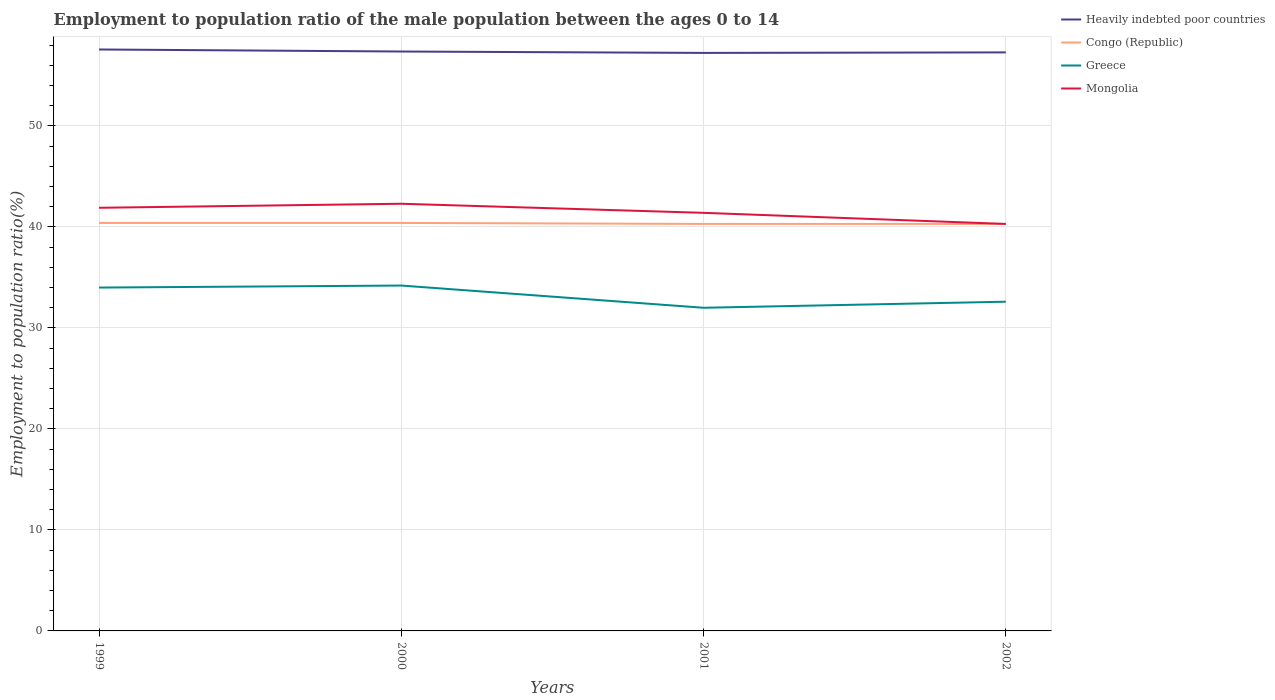Across all years, what is the maximum employment to population ratio in Mongolia?
Offer a very short reply. 40.3. In which year was the employment to population ratio in Mongolia maximum?
Offer a very short reply. 2002. What is the total employment to population ratio in Congo (Republic) in the graph?
Give a very brief answer. 0.1. What is the difference between the highest and the second highest employment to population ratio in Greece?
Provide a succinct answer. 2.2. How many lines are there?
Keep it short and to the point. 4. How many years are there in the graph?
Keep it short and to the point. 4. Are the values on the major ticks of Y-axis written in scientific E-notation?
Your answer should be compact. No. How many legend labels are there?
Provide a short and direct response. 4. How are the legend labels stacked?
Provide a short and direct response. Vertical. What is the title of the graph?
Provide a short and direct response. Employment to population ratio of the male population between the ages 0 to 14. What is the label or title of the X-axis?
Offer a very short reply. Years. What is the Employment to population ratio(%) in Heavily indebted poor countries in 1999?
Provide a succinct answer. 57.57. What is the Employment to population ratio(%) of Congo (Republic) in 1999?
Give a very brief answer. 40.4. What is the Employment to population ratio(%) in Greece in 1999?
Offer a terse response. 34. What is the Employment to population ratio(%) of Mongolia in 1999?
Make the answer very short. 41.9. What is the Employment to population ratio(%) of Heavily indebted poor countries in 2000?
Your answer should be compact. 57.37. What is the Employment to population ratio(%) of Congo (Republic) in 2000?
Provide a short and direct response. 40.4. What is the Employment to population ratio(%) in Greece in 2000?
Provide a short and direct response. 34.2. What is the Employment to population ratio(%) in Mongolia in 2000?
Provide a succinct answer. 42.3. What is the Employment to population ratio(%) of Heavily indebted poor countries in 2001?
Provide a short and direct response. 57.24. What is the Employment to population ratio(%) of Congo (Republic) in 2001?
Give a very brief answer. 40.3. What is the Employment to population ratio(%) in Greece in 2001?
Make the answer very short. 32. What is the Employment to population ratio(%) of Mongolia in 2001?
Offer a terse response. 41.4. What is the Employment to population ratio(%) of Heavily indebted poor countries in 2002?
Your response must be concise. 57.29. What is the Employment to population ratio(%) of Congo (Republic) in 2002?
Provide a short and direct response. 40.3. What is the Employment to population ratio(%) of Greece in 2002?
Your answer should be very brief. 32.6. What is the Employment to population ratio(%) in Mongolia in 2002?
Provide a succinct answer. 40.3. Across all years, what is the maximum Employment to population ratio(%) of Heavily indebted poor countries?
Your answer should be compact. 57.57. Across all years, what is the maximum Employment to population ratio(%) in Congo (Republic)?
Provide a succinct answer. 40.4. Across all years, what is the maximum Employment to population ratio(%) of Greece?
Offer a very short reply. 34.2. Across all years, what is the maximum Employment to population ratio(%) of Mongolia?
Make the answer very short. 42.3. Across all years, what is the minimum Employment to population ratio(%) in Heavily indebted poor countries?
Keep it short and to the point. 57.24. Across all years, what is the minimum Employment to population ratio(%) of Congo (Republic)?
Your response must be concise. 40.3. Across all years, what is the minimum Employment to population ratio(%) of Mongolia?
Keep it short and to the point. 40.3. What is the total Employment to population ratio(%) of Heavily indebted poor countries in the graph?
Give a very brief answer. 229.47. What is the total Employment to population ratio(%) of Congo (Republic) in the graph?
Offer a very short reply. 161.4. What is the total Employment to population ratio(%) of Greece in the graph?
Provide a succinct answer. 132.8. What is the total Employment to population ratio(%) of Mongolia in the graph?
Your response must be concise. 165.9. What is the difference between the Employment to population ratio(%) of Heavily indebted poor countries in 1999 and that in 2000?
Offer a terse response. 0.2. What is the difference between the Employment to population ratio(%) of Greece in 1999 and that in 2000?
Make the answer very short. -0.2. What is the difference between the Employment to population ratio(%) of Mongolia in 1999 and that in 2000?
Your answer should be very brief. -0.4. What is the difference between the Employment to population ratio(%) of Heavily indebted poor countries in 1999 and that in 2001?
Ensure brevity in your answer.  0.34. What is the difference between the Employment to population ratio(%) in Greece in 1999 and that in 2001?
Your answer should be very brief. 2. What is the difference between the Employment to population ratio(%) in Heavily indebted poor countries in 1999 and that in 2002?
Your answer should be very brief. 0.29. What is the difference between the Employment to population ratio(%) of Congo (Republic) in 1999 and that in 2002?
Provide a short and direct response. 0.1. What is the difference between the Employment to population ratio(%) of Heavily indebted poor countries in 2000 and that in 2001?
Provide a short and direct response. 0.14. What is the difference between the Employment to population ratio(%) of Greece in 2000 and that in 2001?
Offer a very short reply. 2.2. What is the difference between the Employment to population ratio(%) of Heavily indebted poor countries in 2000 and that in 2002?
Keep it short and to the point. 0.09. What is the difference between the Employment to population ratio(%) of Greece in 2000 and that in 2002?
Make the answer very short. 1.6. What is the difference between the Employment to population ratio(%) in Mongolia in 2000 and that in 2002?
Keep it short and to the point. 2. What is the difference between the Employment to population ratio(%) in Heavily indebted poor countries in 2001 and that in 2002?
Offer a very short reply. -0.05. What is the difference between the Employment to population ratio(%) in Congo (Republic) in 2001 and that in 2002?
Ensure brevity in your answer.  0. What is the difference between the Employment to population ratio(%) of Heavily indebted poor countries in 1999 and the Employment to population ratio(%) of Congo (Republic) in 2000?
Give a very brief answer. 17.17. What is the difference between the Employment to population ratio(%) in Heavily indebted poor countries in 1999 and the Employment to population ratio(%) in Greece in 2000?
Offer a very short reply. 23.37. What is the difference between the Employment to population ratio(%) of Heavily indebted poor countries in 1999 and the Employment to population ratio(%) of Mongolia in 2000?
Offer a very short reply. 15.27. What is the difference between the Employment to population ratio(%) of Congo (Republic) in 1999 and the Employment to population ratio(%) of Mongolia in 2000?
Offer a very short reply. -1.9. What is the difference between the Employment to population ratio(%) in Heavily indebted poor countries in 1999 and the Employment to population ratio(%) in Congo (Republic) in 2001?
Give a very brief answer. 17.27. What is the difference between the Employment to population ratio(%) in Heavily indebted poor countries in 1999 and the Employment to population ratio(%) in Greece in 2001?
Your answer should be compact. 25.57. What is the difference between the Employment to population ratio(%) of Heavily indebted poor countries in 1999 and the Employment to population ratio(%) of Mongolia in 2001?
Ensure brevity in your answer.  16.17. What is the difference between the Employment to population ratio(%) of Congo (Republic) in 1999 and the Employment to population ratio(%) of Greece in 2001?
Your answer should be very brief. 8.4. What is the difference between the Employment to population ratio(%) in Heavily indebted poor countries in 1999 and the Employment to population ratio(%) in Congo (Republic) in 2002?
Your answer should be compact. 17.27. What is the difference between the Employment to population ratio(%) in Heavily indebted poor countries in 1999 and the Employment to population ratio(%) in Greece in 2002?
Provide a short and direct response. 24.97. What is the difference between the Employment to population ratio(%) of Heavily indebted poor countries in 1999 and the Employment to population ratio(%) of Mongolia in 2002?
Make the answer very short. 17.27. What is the difference between the Employment to population ratio(%) in Congo (Republic) in 1999 and the Employment to population ratio(%) in Greece in 2002?
Provide a short and direct response. 7.8. What is the difference between the Employment to population ratio(%) in Congo (Republic) in 1999 and the Employment to population ratio(%) in Mongolia in 2002?
Your answer should be very brief. 0.1. What is the difference between the Employment to population ratio(%) of Greece in 1999 and the Employment to population ratio(%) of Mongolia in 2002?
Provide a succinct answer. -6.3. What is the difference between the Employment to population ratio(%) in Heavily indebted poor countries in 2000 and the Employment to population ratio(%) in Congo (Republic) in 2001?
Give a very brief answer. 17.07. What is the difference between the Employment to population ratio(%) in Heavily indebted poor countries in 2000 and the Employment to population ratio(%) in Greece in 2001?
Make the answer very short. 25.37. What is the difference between the Employment to population ratio(%) in Heavily indebted poor countries in 2000 and the Employment to population ratio(%) in Mongolia in 2001?
Your response must be concise. 15.97. What is the difference between the Employment to population ratio(%) in Greece in 2000 and the Employment to population ratio(%) in Mongolia in 2001?
Keep it short and to the point. -7.2. What is the difference between the Employment to population ratio(%) of Heavily indebted poor countries in 2000 and the Employment to population ratio(%) of Congo (Republic) in 2002?
Make the answer very short. 17.07. What is the difference between the Employment to population ratio(%) in Heavily indebted poor countries in 2000 and the Employment to population ratio(%) in Greece in 2002?
Keep it short and to the point. 24.77. What is the difference between the Employment to population ratio(%) of Heavily indebted poor countries in 2000 and the Employment to population ratio(%) of Mongolia in 2002?
Keep it short and to the point. 17.07. What is the difference between the Employment to population ratio(%) in Greece in 2000 and the Employment to population ratio(%) in Mongolia in 2002?
Offer a terse response. -6.1. What is the difference between the Employment to population ratio(%) in Heavily indebted poor countries in 2001 and the Employment to population ratio(%) in Congo (Republic) in 2002?
Ensure brevity in your answer.  16.94. What is the difference between the Employment to population ratio(%) in Heavily indebted poor countries in 2001 and the Employment to population ratio(%) in Greece in 2002?
Give a very brief answer. 24.64. What is the difference between the Employment to population ratio(%) in Heavily indebted poor countries in 2001 and the Employment to population ratio(%) in Mongolia in 2002?
Offer a terse response. 16.94. What is the difference between the Employment to population ratio(%) of Congo (Republic) in 2001 and the Employment to population ratio(%) of Greece in 2002?
Give a very brief answer. 7.7. What is the difference between the Employment to population ratio(%) of Congo (Republic) in 2001 and the Employment to population ratio(%) of Mongolia in 2002?
Provide a succinct answer. 0. What is the average Employment to population ratio(%) of Heavily indebted poor countries per year?
Provide a short and direct response. 57.37. What is the average Employment to population ratio(%) of Congo (Republic) per year?
Make the answer very short. 40.35. What is the average Employment to population ratio(%) of Greece per year?
Offer a terse response. 33.2. What is the average Employment to population ratio(%) in Mongolia per year?
Offer a terse response. 41.48. In the year 1999, what is the difference between the Employment to population ratio(%) of Heavily indebted poor countries and Employment to population ratio(%) of Congo (Republic)?
Your answer should be compact. 17.17. In the year 1999, what is the difference between the Employment to population ratio(%) in Heavily indebted poor countries and Employment to population ratio(%) in Greece?
Make the answer very short. 23.57. In the year 1999, what is the difference between the Employment to population ratio(%) of Heavily indebted poor countries and Employment to population ratio(%) of Mongolia?
Provide a short and direct response. 15.67. In the year 1999, what is the difference between the Employment to population ratio(%) in Congo (Republic) and Employment to population ratio(%) in Greece?
Offer a terse response. 6.4. In the year 1999, what is the difference between the Employment to population ratio(%) in Congo (Republic) and Employment to population ratio(%) in Mongolia?
Make the answer very short. -1.5. In the year 1999, what is the difference between the Employment to population ratio(%) of Greece and Employment to population ratio(%) of Mongolia?
Make the answer very short. -7.9. In the year 2000, what is the difference between the Employment to population ratio(%) in Heavily indebted poor countries and Employment to population ratio(%) in Congo (Republic)?
Your response must be concise. 16.97. In the year 2000, what is the difference between the Employment to population ratio(%) of Heavily indebted poor countries and Employment to population ratio(%) of Greece?
Offer a very short reply. 23.17. In the year 2000, what is the difference between the Employment to population ratio(%) in Heavily indebted poor countries and Employment to population ratio(%) in Mongolia?
Give a very brief answer. 15.07. In the year 2000, what is the difference between the Employment to population ratio(%) of Congo (Republic) and Employment to population ratio(%) of Greece?
Give a very brief answer. 6.2. In the year 2000, what is the difference between the Employment to population ratio(%) of Congo (Republic) and Employment to population ratio(%) of Mongolia?
Offer a very short reply. -1.9. In the year 2001, what is the difference between the Employment to population ratio(%) of Heavily indebted poor countries and Employment to population ratio(%) of Congo (Republic)?
Offer a very short reply. 16.94. In the year 2001, what is the difference between the Employment to population ratio(%) of Heavily indebted poor countries and Employment to population ratio(%) of Greece?
Keep it short and to the point. 25.24. In the year 2001, what is the difference between the Employment to population ratio(%) in Heavily indebted poor countries and Employment to population ratio(%) in Mongolia?
Offer a terse response. 15.84. In the year 2002, what is the difference between the Employment to population ratio(%) in Heavily indebted poor countries and Employment to population ratio(%) in Congo (Republic)?
Your answer should be very brief. 16.99. In the year 2002, what is the difference between the Employment to population ratio(%) in Heavily indebted poor countries and Employment to population ratio(%) in Greece?
Your answer should be very brief. 24.69. In the year 2002, what is the difference between the Employment to population ratio(%) of Heavily indebted poor countries and Employment to population ratio(%) of Mongolia?
Offer a very short reply. 16.99. In the year 2002, what is the difference between the Employment to population ratio(%) of Congo (Republic) and Employment to population ratio(%) of Greece?
Your answer should be very brief. 7.7. In the year 2002, what is the difference between the Employment to population ratio(%) in Congo (Republic) and Employment to population ratio(%) in Mongolia?
Your answer should be compact. 0. In the year 2002, what is the difference between the Employment to population ratio(%) of Greece and Employment to population ratio(%) of Mongolia?
Your answer should be very brief. -7.7. What is the ratio of the Employment to population ratio(%) in Heavily indebted poor countries in 1999 to that in 2000?
Keep it short and to the point. 1. What is the ratio of the Employment to population ratio(%) in Congo (Republic) in 1999 to that in 2000?
Ensure brevity in your answer.  1. What is the ratio of the Employment to population ratio(%) of Greece in 1999 to that in 2000?
Give a very brief answer. 0.99. What is the ratio of the Employment to population ratio(%) in Mongolia in 1999 to that in 2000?
Your answer should be very brief. 0.99. What is the ratio of the Employment to population ratio(%) of Heavily indebted poor countries in 1999 to that in 2001?
Ensure brevity in your answer.  1.01. What is the ratio of the Employment to population ratio(%) of Mongolia in 1999 to that in 2001?
Provide a succinct answer. 1.01. What is the ratio of the Employment to population ratio(%) in Congo (Republic) in 1999 to that in 2002?
Make the answer very short. 1. What is the ratio of the Employment to population ratio(%) of Greece in 1999 to that in 2002?
Keep it short and to the point. 1.04. What is the ratio of the Employment to population ratio(%) in Mongolia in 1999 to that in 2002?
Provide a short and direct response. 1.04. What is the ratio of the Employment to population ratio(%) of Greece in 2000 to that in 2001?
Your answer should be very brief. 1.07. What is the ratio of the Employment to population ratio(%) in Mongolia in 2000 to that in 2001?
Your answer should be very brief. 1.02. What is the ratio of the Employment to population ratio(%) in Heavily indebted poor countries in 2000 to that in 2002?
Provide a succinct answer. 1. What is the ratio of the Employment to population ratio(%) in Congo (Republic) in 2000 to that in 2002?
Ensure brevity in your answer.  1. What is the ratio of the Employment to population ratio(%) in Greece in 2000 to that in 2002?
Your answer should be very brief. 1.05. What is the ratio of the Employment to population ratio(%) in Mongolia in 2000 to that in 2002?
Your answer should be very brief. 1.05. What is the ratio of the Employment to population ratio(%) in Heavily indebted poor countries in 2001 to that in 2002?
Keep it short and to the point. 1. What is the ratio of the Employment to population ratio(%) of Congo (Republic) in 2001 to that in 2002?
Offer a terse response. 1. What is the ratio of the Employment to population ratio(%) in Greece in 2001 to that in 2002?
Offer a very short reply. 0.98. What is the ratio of the Employment to population ratio(%) of Mongolia in 2001 to that in 2002?
Give a very brief answer. 1.03. What is the difference between the highest and the second highest Employment to population ratio(%) in Heavily indebted poor countries?
Give a very brief answer. 0.2. What is the difference between the highest and the lowest Employment to population ratio(%) of Heavily indebted poor countries?
Give a very brief answer. 0.34. What is the difference between the highest and the lowest Employment to population ratio(%) of Greece?
Ensure brevity in your answer.  2.2. What is the difference between the highest and the lowest Employment to population ratio(%) in Mongolia?
Your answer should be very brief. 2. 